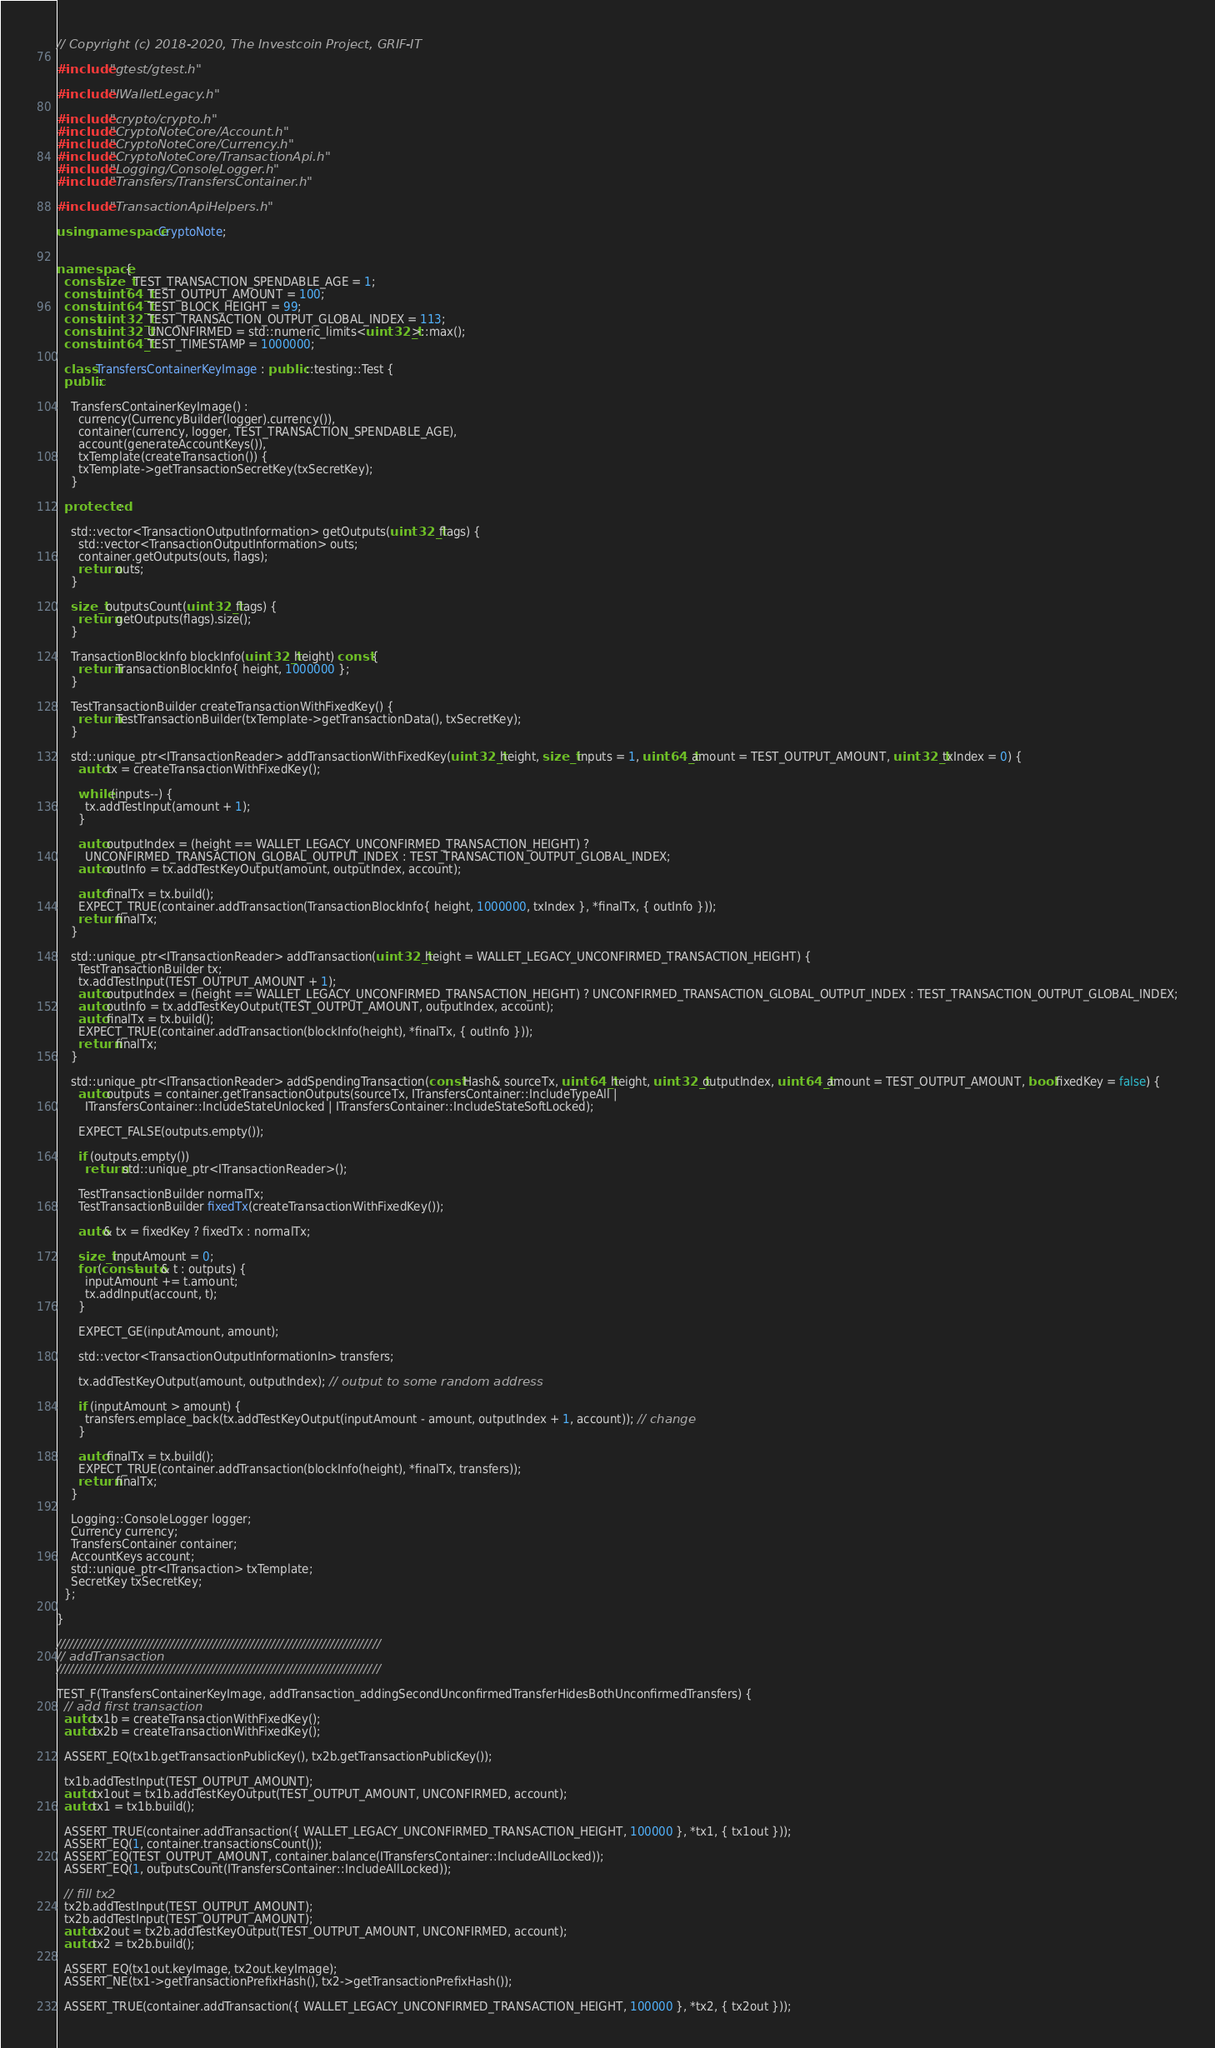<code> <loc_0><loc_0><loc_500><loc_500><_C++_>// Copyright (c) 2018-2020, The Investcoin Project, GRIF-IT

#include "gtest/gtest.h"

#include "IWalletLegacy.h"

#include "crypto/crypto.h"
#include "CryptoNoteCore/Account.h"
#include "CryptoNoteCore/Currency.h"
#include "CryptoNoteCore/TransactionApi.h"
#include "Logging/ConsoleLogger.h"
#include "Transfers/TransfersContainer.h"

#include "TransactionApiHelpers.h"

using namespace CryptoNote;


namespace {
  const size_t TEST_TRANSACTION_SPENDABLE_AGE = 1;
  const uint64_t TEST_OUTPUT_AMOUNT = 100;
  const uint64_t TEST_BLOCK_HEIGHT = 99;
  const uint32_t TEST_TRANSACTION_OUTPUT_GLOBAL_INDEX = 113;
  const uint32_t UNCONFIRMED = std::numeric_limits<uint32_t>::max();
  const uint64_t TEST_TIMESTAMP = 1000000;

  class TransfersContainerKeyImage : public ::testing::Test {
  public:

    TransfersContainerKeyImage() :
      currency(CurrencyBuilder(logger).currency()), 
      container(currency, logger, TEST_TRANSACTION_SPENDABLE_AGE), 
      account(generateAccountKeys()),
      txTemplate(createTransaction()) {
      txTemplate->getTransactionSecretKey(txSecretKey);
    }

  protected:

    std::vector<TransactionOutputInformation> getOutputs(uint32_t flags) {
      std::vector<TransactionOutputInformation> outs;
      container.getOutputs(outs, flags);
      return outs;
    }

    size_t outputsCount(uint32_t flags) {
      return getOutputs(flags).size();
    }

    TransactionBlockInfo blockInfo(uint32_t height) const {
      return TransactionBlockInfo{ height, 1000000 };
    }

    TestTransactionBuilder createTransactionWithFixedKey() {
      return TestTransactionBuilder(txTemplate->getTransactionData(), txSecretKey);
    }

    std::unique_ptr<ITransactionReader> addTransactionWithFixedKey(uint32_t height, size_t inputs = 1, uint64_t amount = TEST_OUTPUT_AMOUNT, uint32_t txIndex = 0) {
      auto tx = createTransactionWithFixedKey();
      
      while (inputs--) {
        tx.addTestInput(amount + 1);
      }

      auto outputIndex = (height == WALLET_LEGACY_UNCONFIRMED_TRANSACTION_HEIGHT) ? 
        UNCONFIRMED_TRANSACTION_GLOBAL_OUTPUT_INDEX : TEST_TRANSACTION_OUTPUT_GLOBAL_INDEX;
      auto outInfo = tx.addTestKeyOutput(amount, outputIndex, account);

      auto finalTx = tx.build();
      EXPECT_TRUE(container.addTransaction(TransactionBlockInfo{ height, 1000000, txIndex }, *finalTx, { outInfo }));
      return finalTx;
    }

    std::unique_ptr<ITransactionReader> addTransaction(uint32_t height = WALLET_LEGACY_UNCONFIRMED_TRANSACTION_HEIGHT) {
      TestTransactionBuilder tx;
      tx.addTestInput(TEST_OUTPUT_AMOUNT + 1);
      auto outputIndex = (height == WALLET_LEGACY_UNCONFIRMED_TRANSACTION_HEIGHT) ? UNCONFIRMED_TRANSACTION_GLOBAL_OUTPUT_INDEX : TEST_TRANSACTION_OUTPUT_GLOBAL_INDEX;
      auto outInfo = tx.addTestKeyOutput(TEST_OUTPUT_AMOUNT, outputIndex, account);
      auto finalTx = tx.build();
      EXPECT_TRUE(container.addTransaction(blockInfo(height), *finalTx, { outInfo }));
      return finalTx;
    }

    std::unique_ptr<ITransactionReader> addSpendingTransaction(const Hash& sourceTx, uint64_t height, uint32_t outputIndex, uint64_t amount = TEST_OUTPUT_AMOUNT, bool fixedKey = false) {
      auto outputs = container.getTransactionOutputs(sourceTx, ITransfersContainer::IncludeTypeAll |
        ITransfersContainer::IncludeStateUnlocked | ITransfersContainer::IncludeStateSoftLocked);

      EXPECT_FALSE(outputs.empty());

      if (outputs.empty())
        return std::unique_ptr<ITransactionReader>();

      TestTransactionBuilder normalTx;
      TestTransactionBuilder fixedTx(createTransactionWithFixedKey());

      auto& tx = fixedKey ? fixedTx : normalTx;

      size_t inputAmount = 0;
      for (const auto& t : outputs) {
        inputAmount += t.amount;
        tx.addInput(account, t);
      }

      EXPECT_GE(inputAmount, amount);

      std::vector<TransactionOutputInformationIn> transfers;

      tx.addTestKeyOutput(amount, outputIndex); // output to some random address

      if (inputAmount > amount) {
        transfers.emplace_back(tx.addTestKeyOutput(inputAmount - amount, outputIndex + 1, account)); // change
      }

      auto finalTx = tx.build();
      EXPECT_TRUE(container.addTransaction(blockInfo(height), *finalTx, transfers));
      return finalTx;
    }

    Logging::ConsoleLogger logger;
    Currency currency;
    TransfersContainer container;
    AccountKeys account;
    std::unique_ptr<ITransaction> txTemplate;
    SecretKey txSecretKey;
  };

}

/////////////////////////////////////////////////////////////////////////////
// addTransaction
/////////////////////////////////////////////////////////////////////////////

TEST_F(TransfersContainerKeyImage, addTransaction_addingSecondUnconfirmedTransferHidesBothUnconfirmedTransfers) {
  // add first transaction
  auto tx1b = createTransactionWithFixedKey();
  auto tx2b = createTransactionWithFixedKey();

  ASSERT_EQ(tx1b.getTransactionPublicKey(), tx2b.getTransactionPublicKey());

  tx1b.addTestInput(TEST_OUTPUT_AMOUNT);
  auto tx1out = tx1b.addTestKeyOutput(TEST_OUTPUT_AMOUNT, UNCONFIRMED, account);
  auto tx1 = tx1b.build();

  ASSERT_TRUE(container.addTransaction({ WALLET_LEGACY_UNCONFIRMED_TRANSACTION_HEIGHT, 100000 }, *tx1, { tx1out }));
  ASSERT_EQ(1, container.transactionsCount());
  ASSERT_EQ(TEST_OUTPUT_AMOUNT, container.balance(ITransfersContainer::IncludeAllLocked));
  ASSERT_EQ(1, outputsCount(ITransfersContainer::IncludeAllLocked));
  
  // fill tx2
  tx2b.addTestInput(TEST_OUTPUT_AMOUNT);
  tx2b.addTestInput(TEST_OUTPUT_AMOUNT);
  auto tx2out = tx2b.addTestKeyOutput(TEST_OUTPUT_AMOUNT, UNCONFIRMED, account);
  auto tx2 = tx2b.build();

  ASSERT_EQ(tx1out.keyImage, tx2out.keyImage);
  ASSERT_NE(tx1->getTransactionPrefixHash(), tx2->getTransactionPrefixHash());

  ASSERT_TRUE(container.addTransaction({ WALLET_LEGACY_UNCONFIRMED_TRANSACTION_HEIGHT, 100000 }, *tx2, { tx2out }));
</code> 